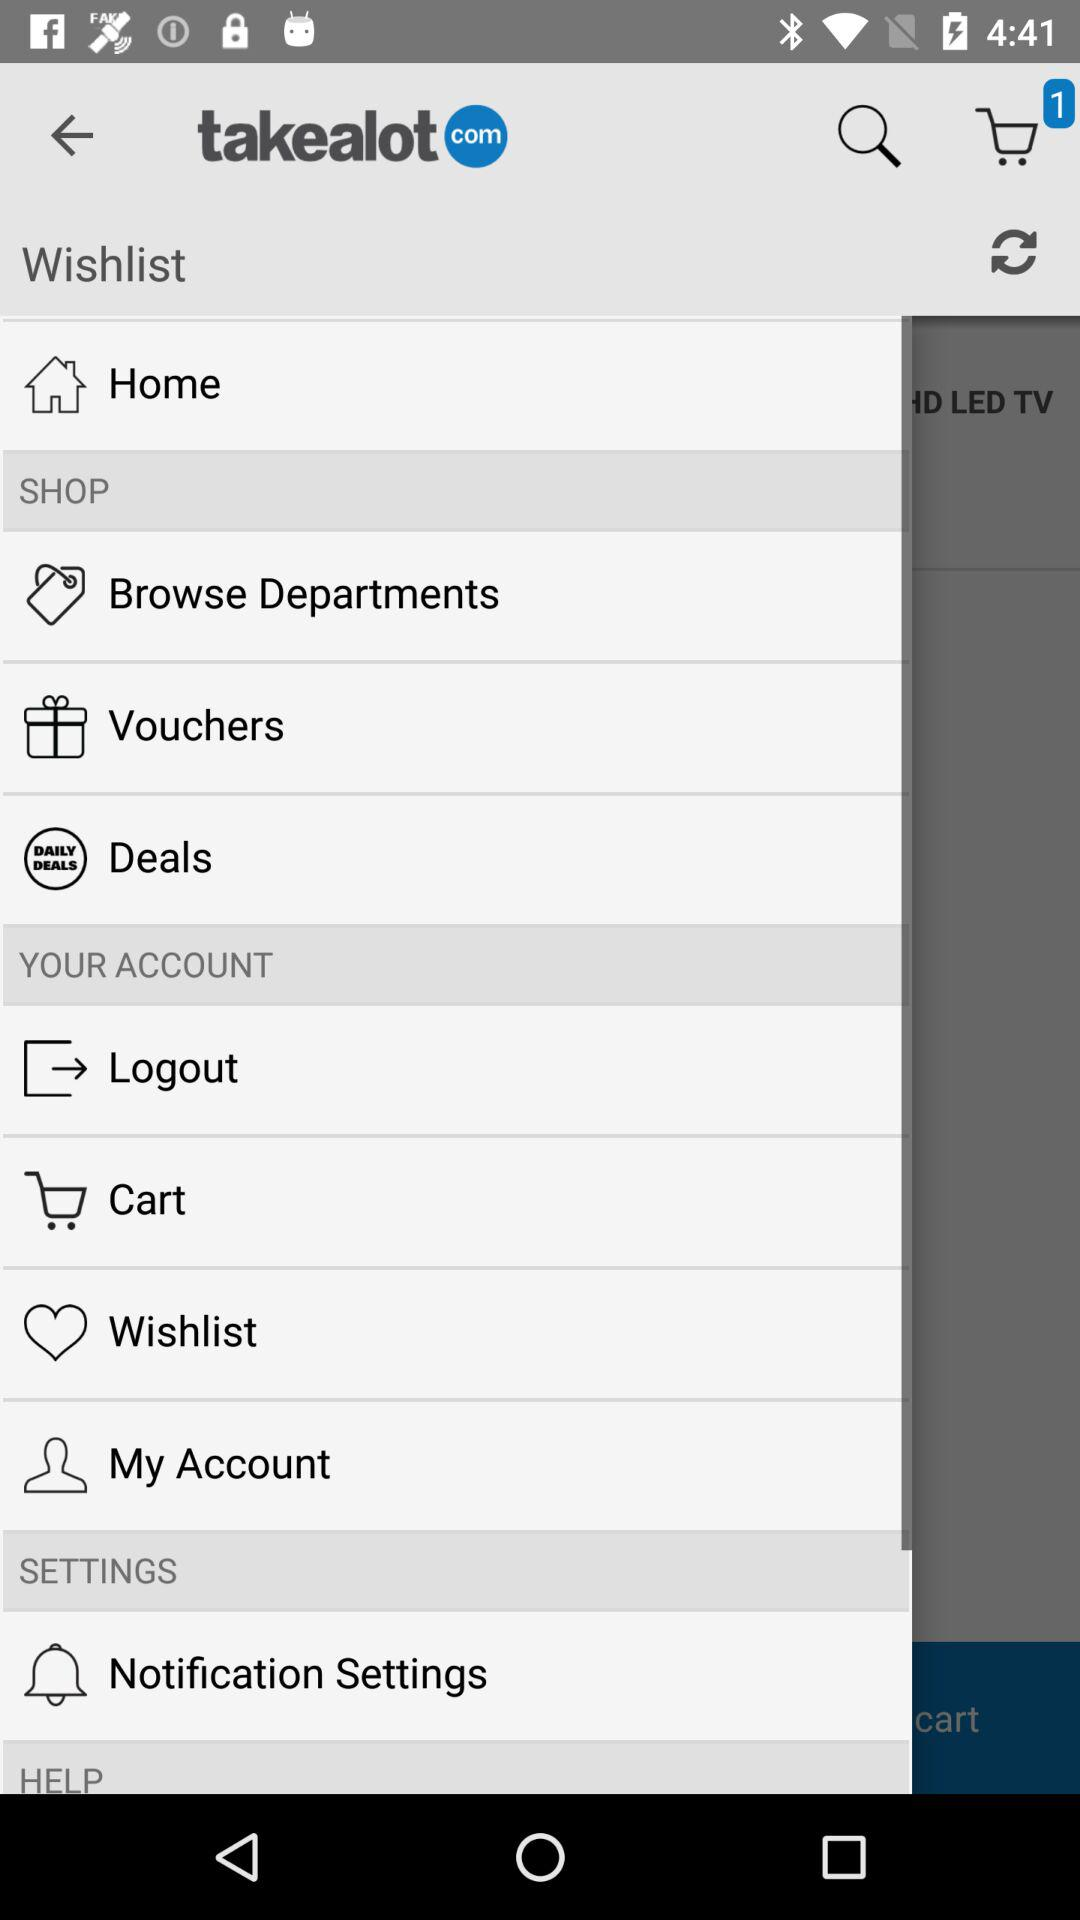How many items are in the shopping cart?
Answer the question using a single word or phrase. 1 